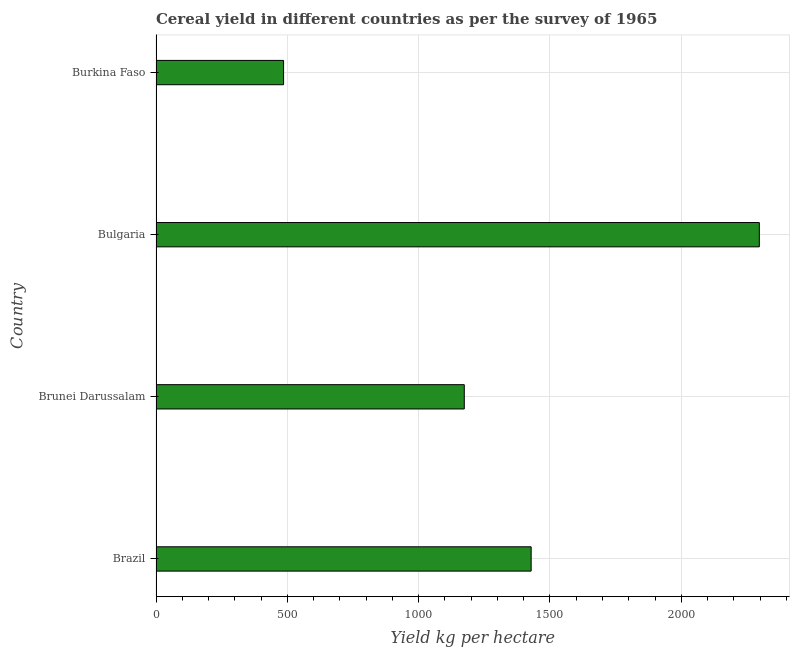Does the graph contain any zero values?
Your answer should be very brief. No. Does the graph contain grids?
Offer a terse response. Yes. What is the title of the graph?
Keep it short and to the point. Cereal yield in different countries as per the survey of 1965. What is the label or title of the X-axis?
Your answer should be very brief. Yield kg per hectare. What is the cereal yield in Brunei Darussalam?
Your response must be concise. 1173.7. Across all countries, what is the maximum cereal yield?
Provide a succinct answer. 2297.09. Across all countries, what is the minimum cereal yield?
Make the answer very short. 485.69. In which country was the cereal yield minimum?
Offer a terse response. Burkina Faso. What is the sum of the cereal yield?
Your answer should be very brief. 5384.82. What is the difference between the cereal yield in Brunei Darussalam and Bulgaria?
Make the answer very short. -1123.38. What is the average cereal yield per country?
Provide a succinct answer. 1346.2. What is the median cereal yield?
Ensure brevity in your answer.  1301.02. What is the ratio of the cereal yield in Brazil to that in Brunei Darussalam?
Give a very brief answer. 1.22. Is the difference between the cereal yield in Brazil and Burkina Faso greater than the difference between any two countries?
Your answer should be compact. No. What is the difference between the highest and the second highest cereal yield?
Your response must be concise. 868.76. Is the sum of the cereal yield in Bulgaria and Burkina Faso greater than the maximum cereal yield across all countries?
Offer a very short reply. Yes. What is the difference between the highest and the lowest cereal yield?
Provide a short and direct response. 1811.4. How many countries are there in the graph?
Give a very brief answer. 4. Are the values on the major ticks of X-axis written in scientific E-notation?
Offer a very short reply. No. What is the Yield kg per hectare in Brazil?
Make the answer very short. 1428.33. What is the Yield kg per hectare of Brunei Darussalam?
Your response must be concise. 1173.7. What is the Yield kg per hectare of Bulgaria?
Your answer should be very brief. 2297.09. What is the Yield kg per hectare in Burkina Faso?
Your answer should be compact. 485.69. What is the difference between the Yield kg per hectare in Brazil and Brunei Darussalam?
Offer a terse response. 254.63. What is the difference between the Yield kg per hectare in Brazil and Bulgaria?
Your response must be concise. -868.76. What is the difference between the Yield kg per hectare in Brazil and Burkina Faso?
Your answer should be very brief. 942.64. What is the difference between the Yield kg per hectare in Brunei Darussalam and Bulgaria?
Offer a terse response. -1123.38. What is the difference between the Yield kg per hectare in Brunei Darussalam and Burkina Faso?
Provide a short and direct response. 688.02. What is the difference between the Yield kg per hectare in Bulgaria and Burkina Faso?
Your response must be concise. 1811.4. What is the ratio of the Yield kg per hectare in Brazil to that in Brunei Darussalam?
Keep it short and to the point. 1.22. What is the ratio of the Yield kg per hectare in Brazil to that in Bulgaria?
Ensure brevity in your answer.  0.62. What is the ratio of the Yield kg per hectare in Brazil to that in Burkina Faso?
Ensure brevity in your answer.  2.94. What is the ratio of the Yield kg per hectare in Brunei Darussalam to that in Bulgaria?
Your answer should be compact. 0.51. What is the ratio of the Yield kg per hectare in Brunei Darussalam to that in Burkina Faso?
Give a very brief answer. 2.42. What is the ratio of the Yield kg per hectare in Bulgaria to that in Burkina Faso?
Offer a very short reply. 4.73. 